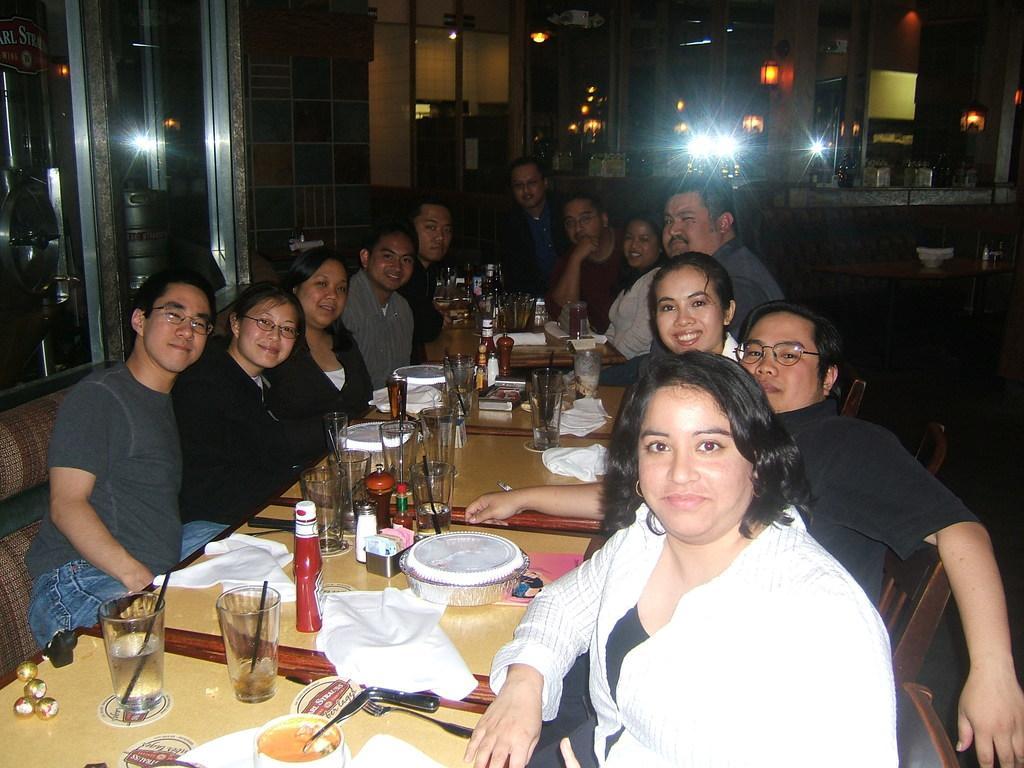Please provide a concise description of this image. In this image we can see a group of people sitting on the chairs beside a table containing some plates, glasses, chocolates, bowl, knives, fork, tissue papers, bottles and some objects on it. On the backside we can see the windows, wall and some lights. 